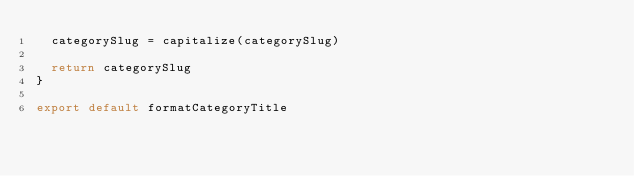<code> <loc_0><loc_0><loc_500><loc_500><_JavaScript_>  categorySlug = capitalize(categorySlug)

  return categorySlug
}

export default formatCategoryTitle
</code> 